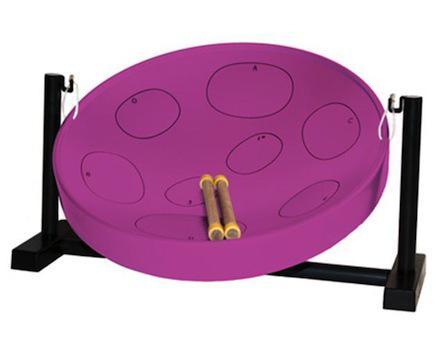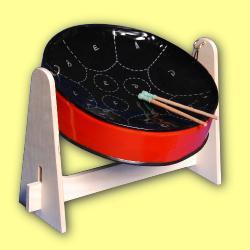The first image is the image on the left, the second image is the image on the right. Considering the images on both sides, is "Each image shows one tilted cylindrical bowl-type drum on a pivoting stand, and the drum on the right has a red exterior and black bowl top." valid? Answer yes or no. Yes. The first image is the image on the left, the second image is the image on the right. Analyze the images presented: Is the assertion "All the drumsticks are resting on the drum head." valid? Answer yes or no. Yes. 